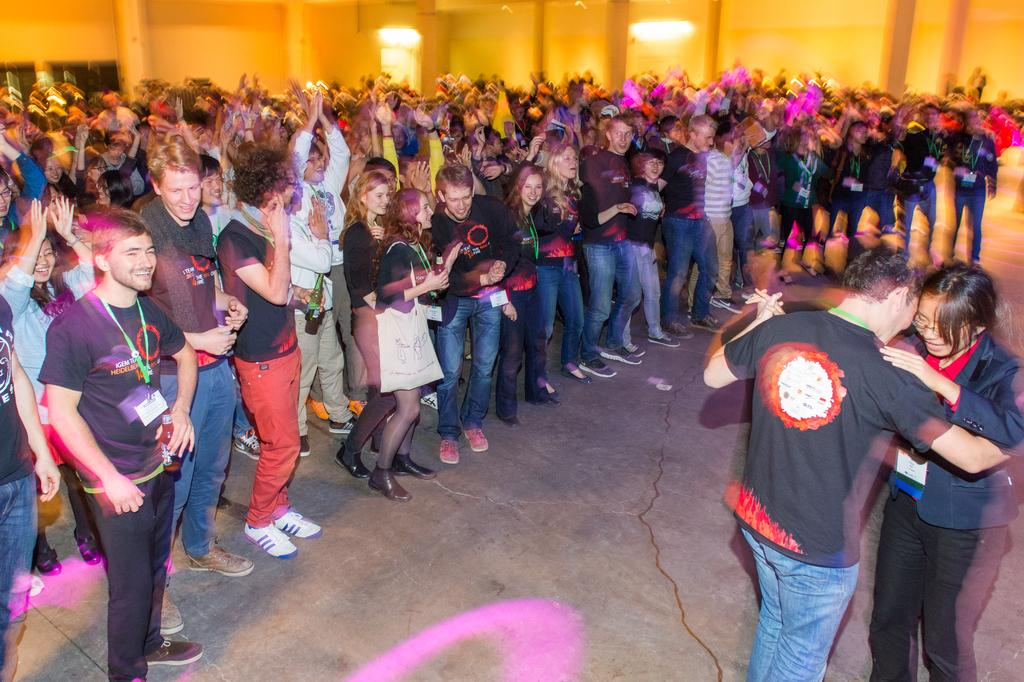What is happening in the image involving people? There are people standing in the image, and a couple is dancing. Where is the dancing couple located in the image? The couple is on the right side of the image. What can be seen in the background of the image? There is a yellow color wall in the background of the image. How many loaves of bread can be seen on the table in the image? There is no table or bread present in the image. What type of rabbits are visible in the image? There are no rabbits present in the image. 